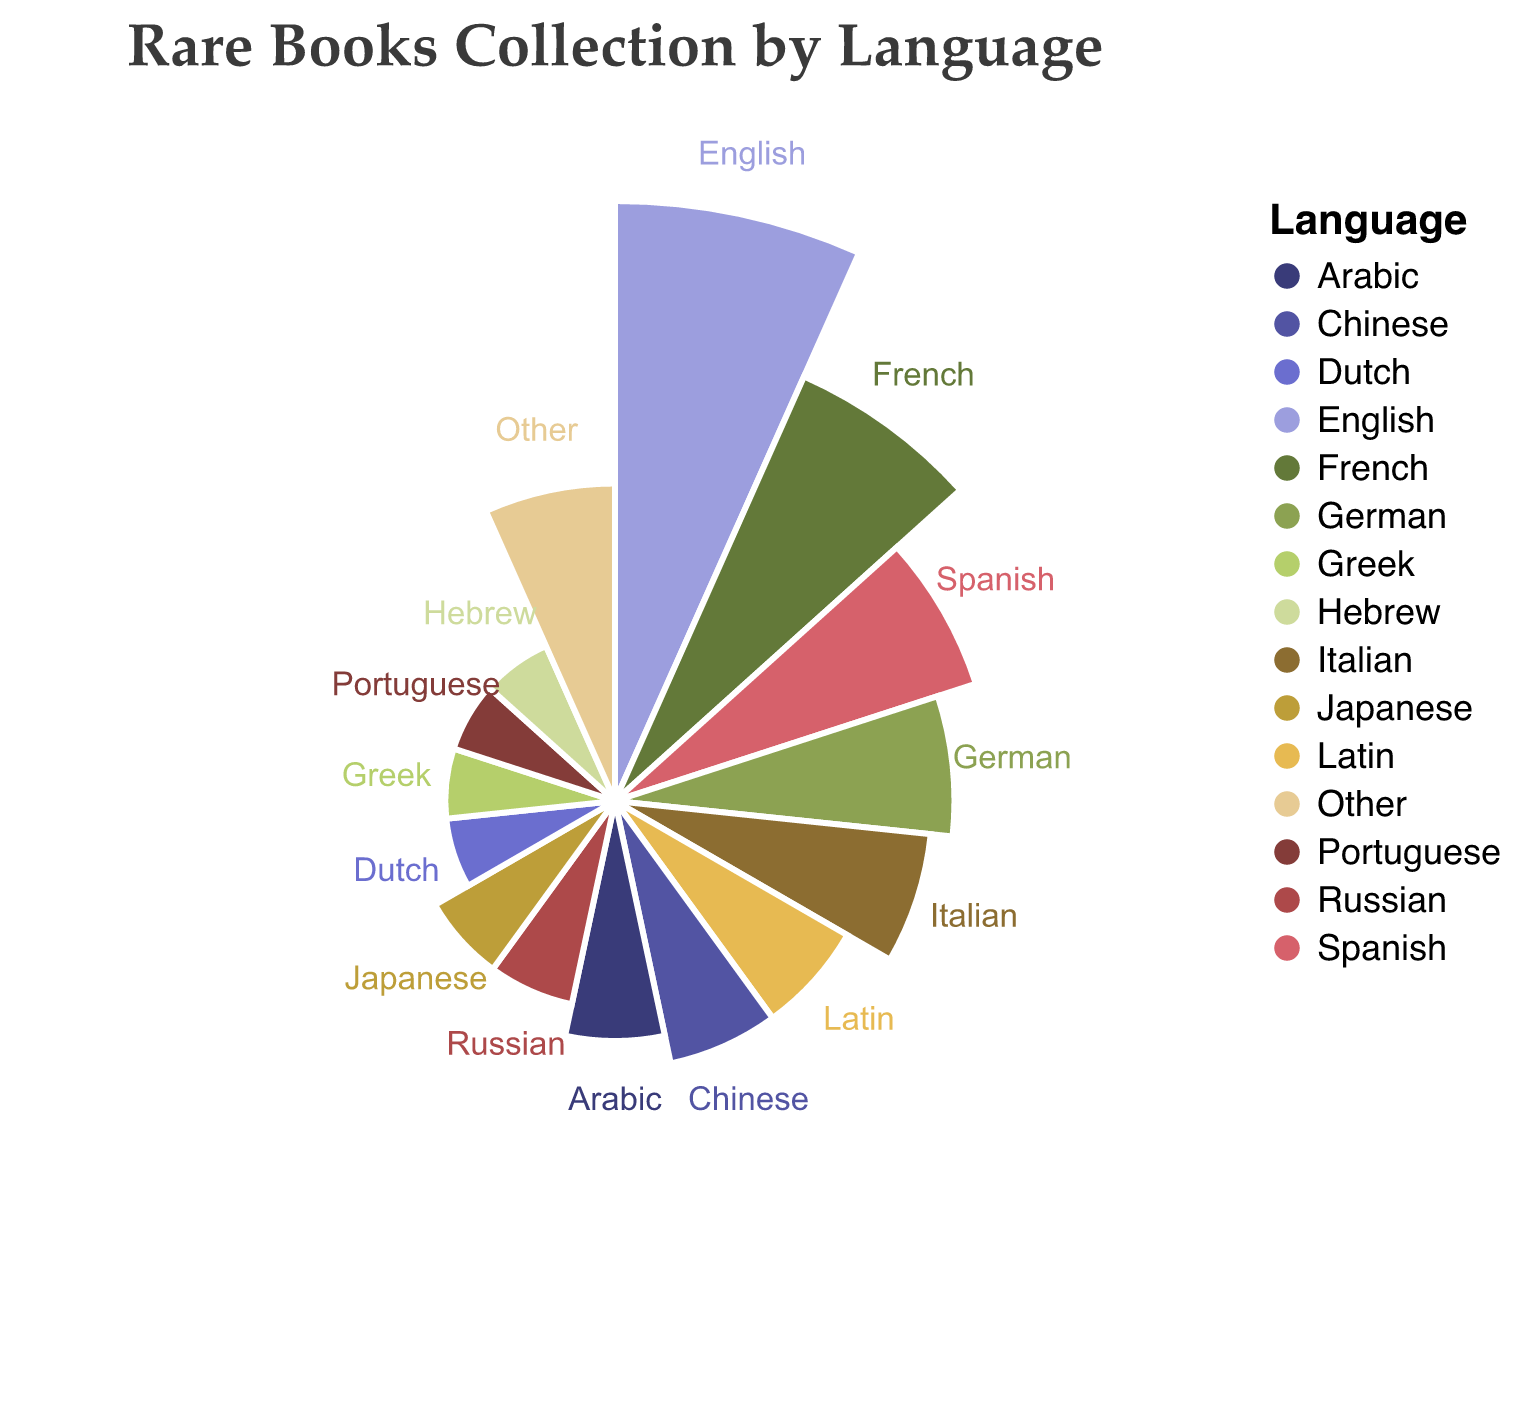How many languages have books making up 2% of the collection? Identify the segments representing 2% and count how many there are. These languages are Dutch, Greek, Portuguese, and Hebrew.
Answer: 4 What language represents the highest percentage of your collection? Look for the segment with the largest radius, labeled 25%. This corresponds to books written in English.
Answer: English What is the combined percentage of books in French and Spanish? Locate the segments for French (15%) and Spanish (10%). Sum these percentages: 15% + 10% = 25%.
Answer: 25% Which language has a larger segment: Arabic or Latin? Compare the segments labeled 4% for Arabic and 5% for Latin.
Answer: Latin How many languages consist of less than 5% of the collection each? Identify all segments with a percentage less than 5%. These are Arabic, Russian, Japanese, Dutch, Greek, Portuguese, and Hebrew. Count these segments: 7 languages.
Answer: 7 What is the difference in percentage between books written in Italian and books written in German? Locate the segments for Italian (7%) and German (8%). Subtract the smaller percentage from the larger percentage: 8% - 7% = 1%.
Answer: 1% What languages contribute exactly 5% to the collection? Identify the segments marked 5%. These languages are Latin and Chinese.
Answer: Latin, Chinese Which language has a segment size equal to that of the "Other" category? Locate the "Other" segment which has a percentage of 7%. Verify languages with the same percentage size. The Italian segment also represents 7%.
Answer: Italian What is the total percentage of books written in non-European languages among the identified segments? Identify non-European languages: Chinese (5%), Arabic (4%), Japanese (3%), Hebrew (2%), Other (7%, only a subset might be non-European, but without detailed breakdown, we include 7%). Sum these: 5% + 4% + 3% + 2% + 7% = 21%.
Answer: 21% Which category has a higher percentage, Spanish or the combination of Russian and Japanese? Compare the percentages: Spanish is 10%, Russian and Japanese combined is 3% + 3% = 6%.
Answer: Spanish 